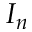<formula> <loc_0><loc_0><loc_500><loc_500>I _ { n }</formula> 